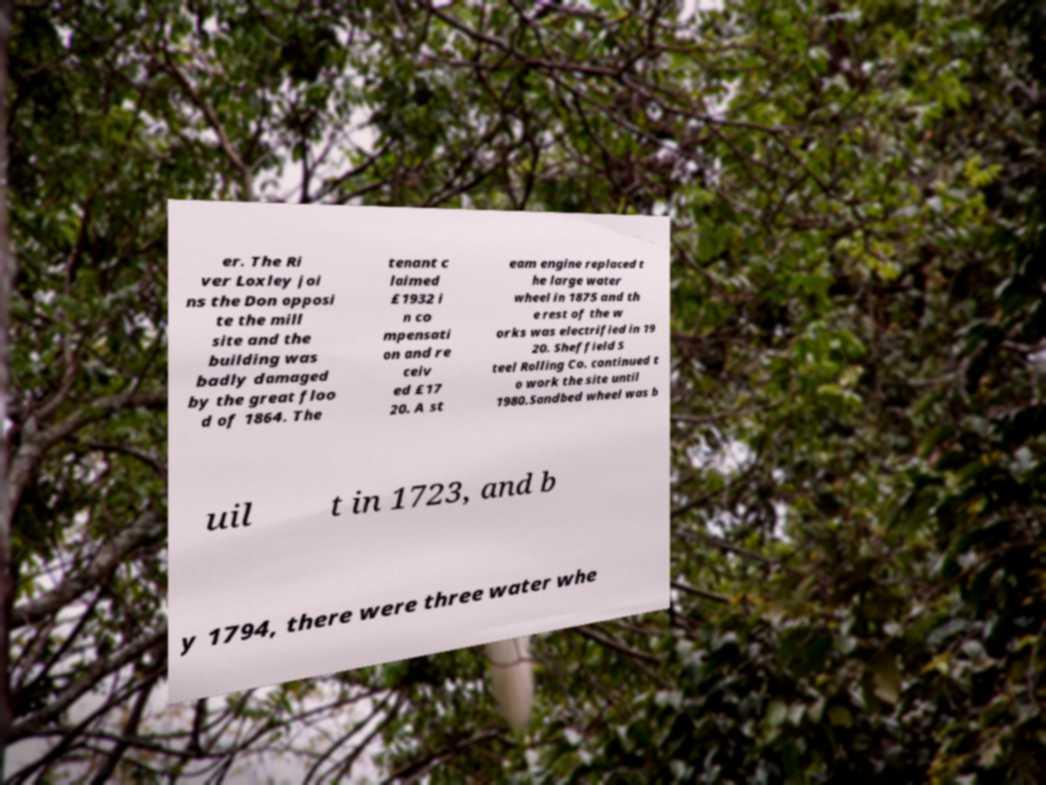Please read and relay the text visible in this image. What does it say? er. The Ri ver Loxley joi ns the Don opposi te the mill site and the building was badly damaged by the great floo d of 1864. The tenant c laimed £1932 i n co mpensati on and re ceiv ed £17 20. A st eam engine replaced t he large water wheel in 1875 and th e rest of the w orks was electrified in 19 20. Sheffield S teel Rolling Co. continued t o work the site until 1980.Sandbed wheel was b uil t in 1723, and b y 1794, there were three water whe 